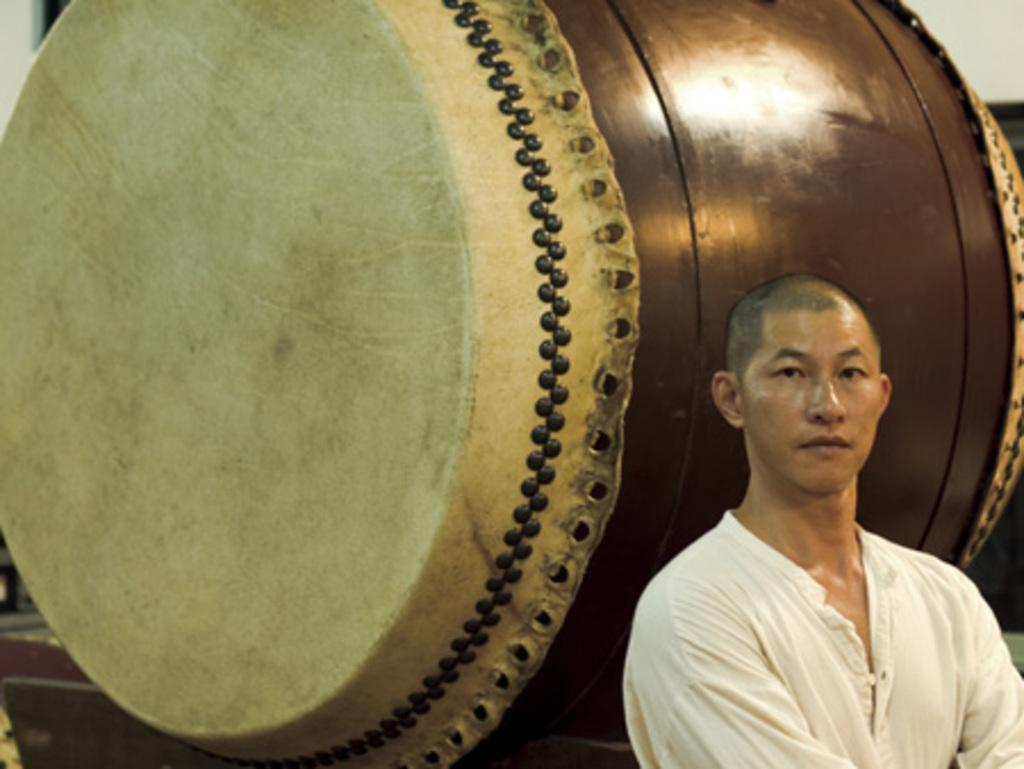What is the position of the man in the image? The man is standing on the right side of the image. Can you describe the wooden object in the image? Unfortunately, there is not enough information provided to describe the wooden object in the image. How many wishes does the toad in the image grant? There is no toad present in the image, so it cannot be determined how many wishes it might grant. 